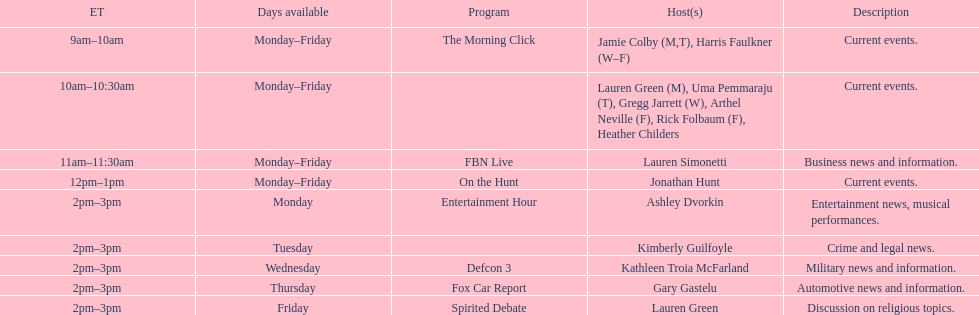Could you parse the entire table? {'header': ['ET', 'Days available', 'Program', 'Host(s)', 'Description'], 'rows': [['9am–10am', 'Monday–Friday', 'The Morning Click', 'Jamie Colby (M,T), Harris Faulkner (W–F)', 'Current events.'], ['10am–10:30am', 'Monday–Friday', '', 'Lauren Green (M), Uma Pemmaraju (T), Gregg Jarrett (W), Arthel Neville (F), Rick Folbaum (F), Heather Childers', 'Current events.'], ['11am–11:30am', 'Monday–Friday', 'FBN Live', 'Lauren Simonetti', 'Business news and information.'], ['12pm–1pm', 'Monday–Friday', 'On the Hunt', 'Jonathan Hunt', 'Current events.'], ['2pm–3pm', 'Monday', 'Entertainment Hour', 'Ashley Dvorkin', 'Entertainment news, musical performances.'], ['2pm–3pm', 'Tuesday', '', 'Kimberly Guilfoyle', 'Crime and legal news.'], ['2pm–3pm', 'Wednesday', 'Defcon 3', 'Kathleen Troia McFarland', 'Military news and information.'], ['2pm–3pm', 'Thursday', 'Fox Car Report', 'Gary Gastelu', 'Automotive news and information.'], ['2pm–3pm', 'Friday', 'Spirited Debate', 'Lauren Green', 'Discussion on religious topics.']]} Over how many days weekly is fbn live available? 5. 